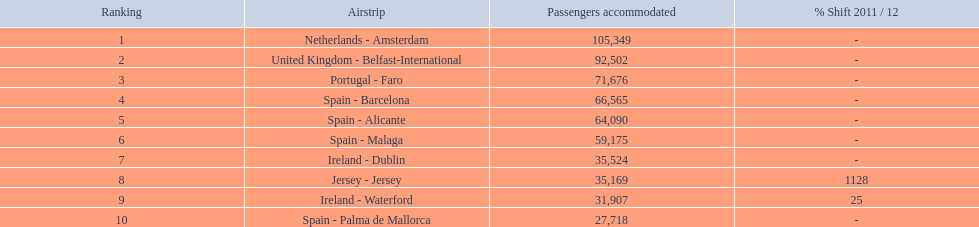What are all of the destinations out of the london southend airport? Netherlands - Amsterdam, United Kingdom - Belfast-International, Portugal - Faro, Spain - Barcelona, Spain - Alicante, Spain - Malaga, Ireland - Dublin, Jersey - Jersey, Ireland - Waterford, Spain - Palma de Mallorca. How many passengers has each destination handled? 105,349, 92,502, 71,676, 66,565, 64,090, 59,175, 35,524, 35,169, 31,907, 27,718. And of those, which airport handled the fewest passengers? Spain - Palma de Mallorca. 